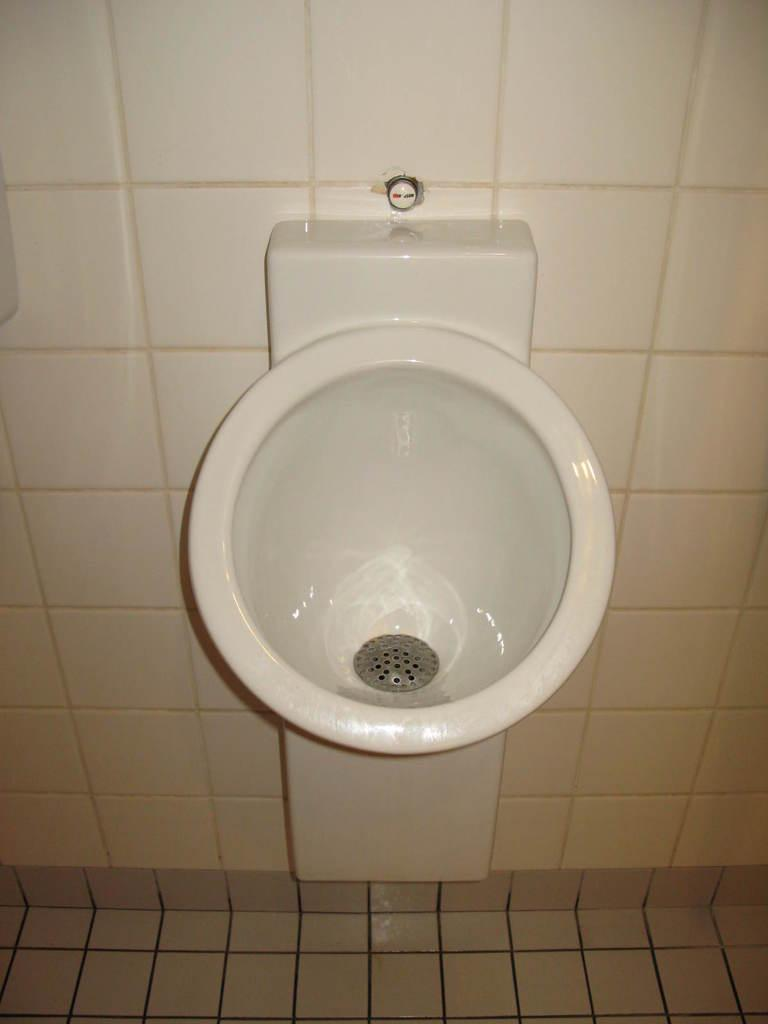What is the main object in the image? There is a washbasin in the image. How is the washbasin positioned in the image? The washbasin is mounted on the wall. What language is spoken by the washbasin in the image? The washbasin does not speak any language, as it is an inanimate object. 